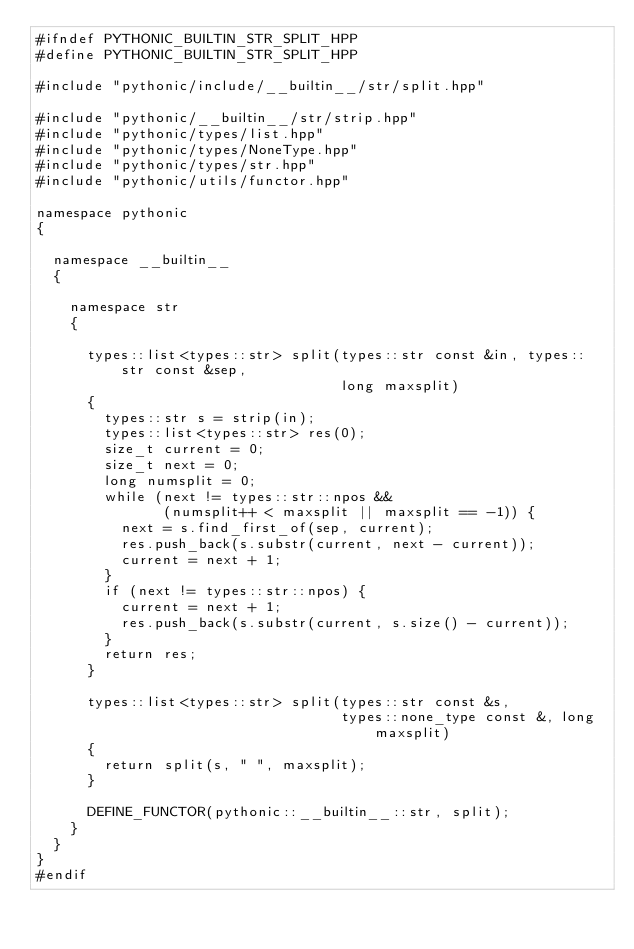<code> <loc_0><loc_0><loc_500><loc_500><_C++_>#ifndef PYTHONIC_BUILTIN_STR_SPLIT_HPP
#define PYTHONIC_BUILTIN_STR_SPLIT_HPP

#include "pythonic/include/__builtin__/str/split.hpp"

#include "pythonic/__builtin__/str/strip.hpp"
#include "pythonic/types/list.hpp"
#include "pythonic/types/NoneType.hpp"
#include "pythonic/types/str.hpp"
#include "pythonic/utils/functor.hpp"

namespace pythonic
{

  namespace __builtin__
  {

    namespace str
    {

      types::list<types::str> split(types::str const &in, types::str const &sep,
                                    long maxsplit)
      {
        types::str s = strip(in);
        types::list<types::str> res(0);
        size_t current = 0;
        size_t next = 0;
        long numsplit = 0;
        while (next != types::str::npos &&
               (numsplit++ < maxsplit || maxsplit == -1)) {
          next = s.find_first_of(sep, current);
          res.push_back(s.substr(current, next - current));
          current = next + 1;
        }
        if (next != types::str::npos) {
          current = next + 1;
          res.push_back(s.substr(current, s.size() - current));
        }
        return res;
      }

      types::list<types::str> split(types::str const &s,
                                    types::none_type const &, long maxsplit)
      {
        return split(s, " ", maxsplit);
      }

      DEFINE_FUNCTOR(pythonic::__builtin__::str, split);
    }
  }
}
#endif
</code> 